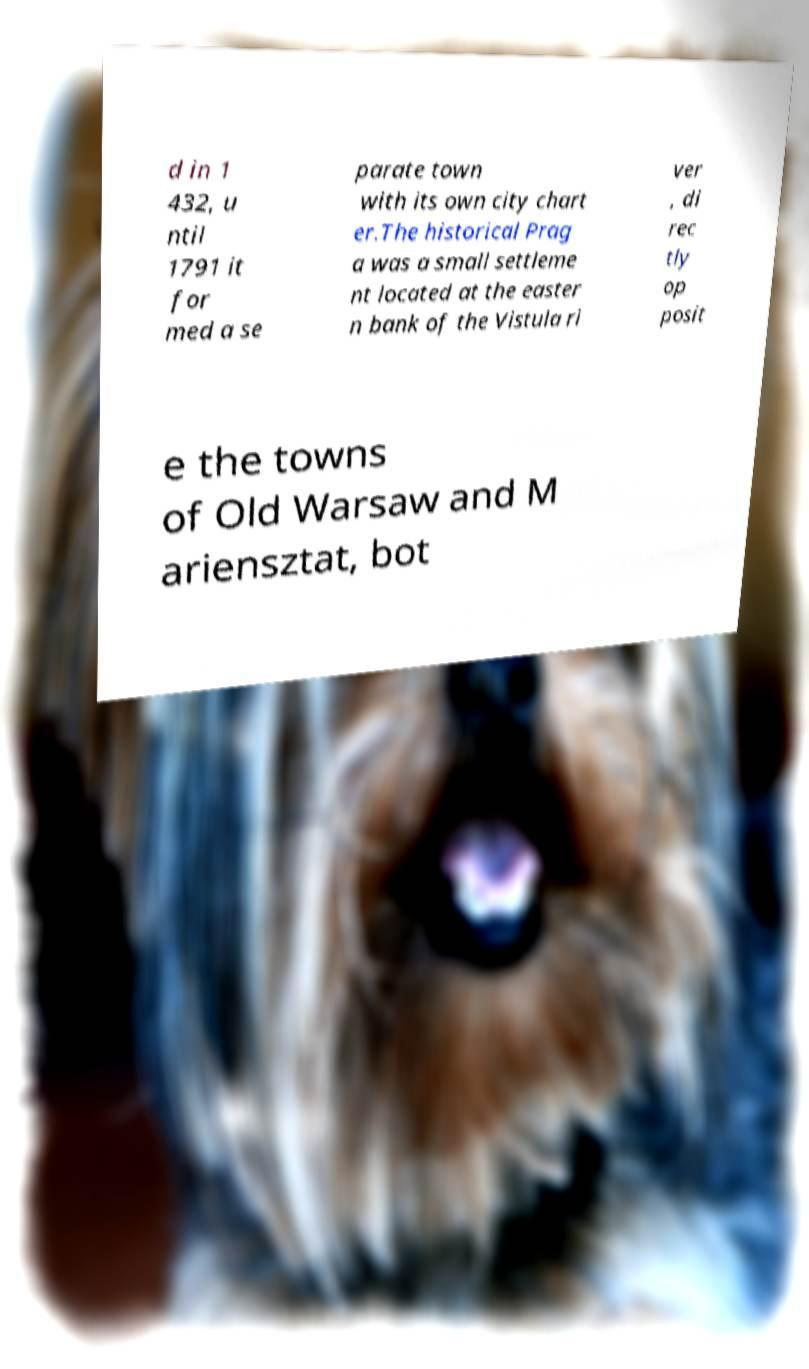For documentation purposes, I need the text within this image transcribed. Could you provide that? d in 1 432, u ntil 1791 it for med a se parate town with its own city chart er.The historical Prag a was a small settleme nt located at the easter n bank of the Vistula ri ver , di rec tly op posit e the towns of Old Warsaw and M ariensztat, bot 